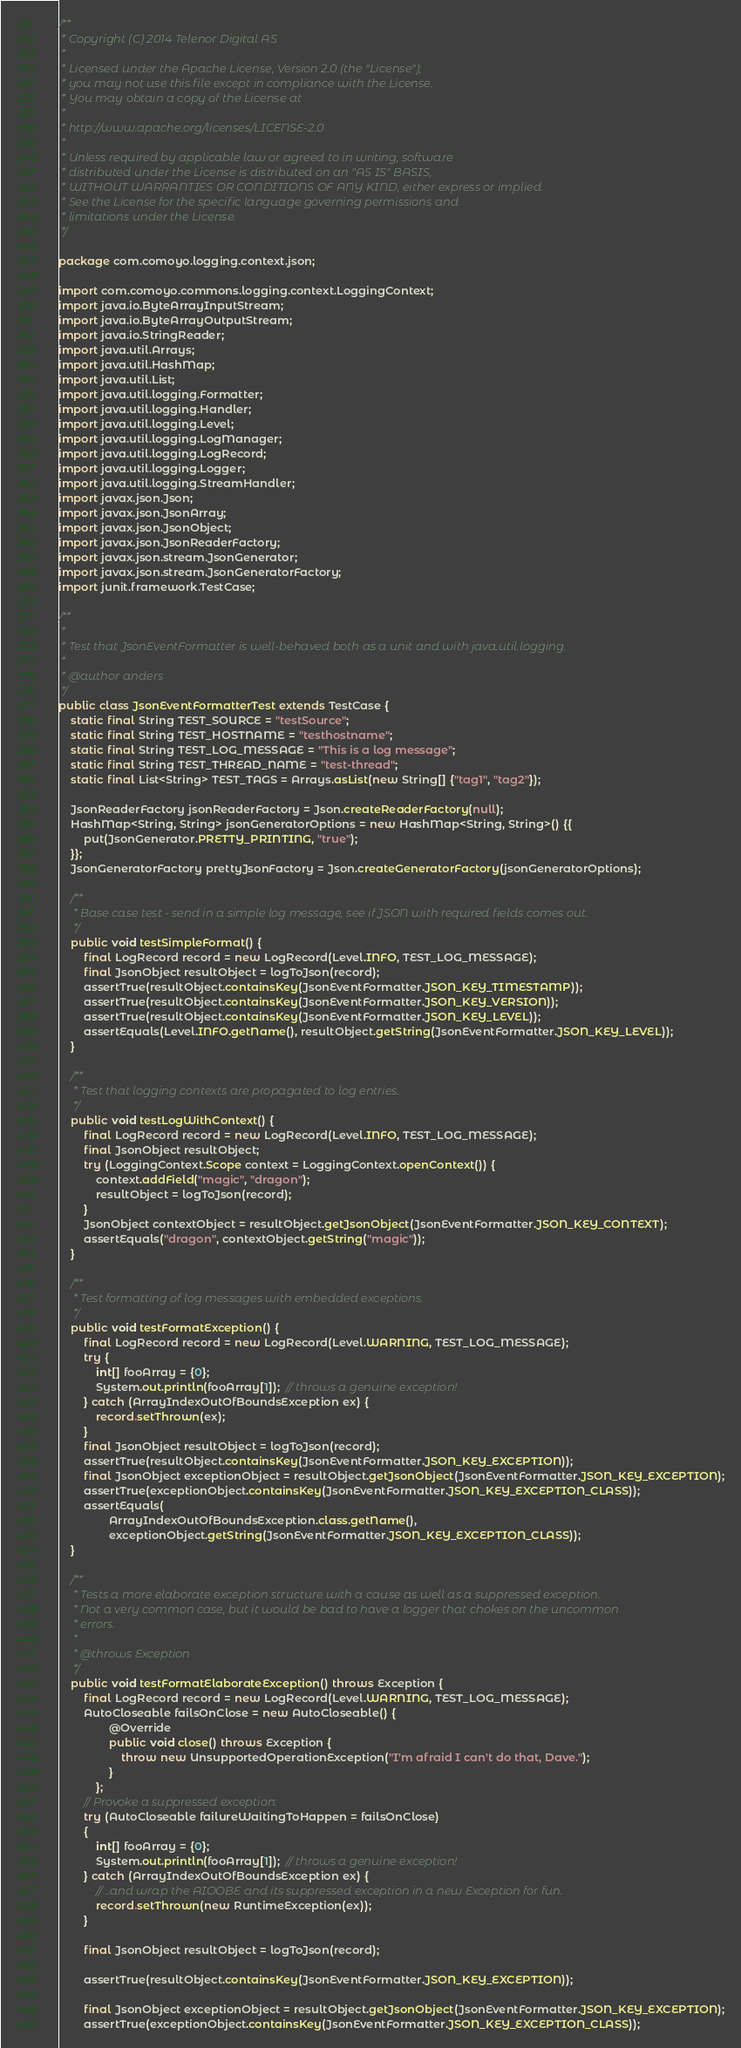Convert code to text. <code><loc_0><loc_0><loc_500><loc_500><_Java_>/**
 * Copyright (C) 2014 Telenor Digital AS
 *
 * Licensed under the Apache License, Version 2.0 (the "License");
 * you may not use this file except in compliance with the License.
 * You may obtain a copy of the License at
 *
 * http://www.apache.org/licenses/LICENSE-2.0
 *
 * Unless required by applicable law or agreed to in writing, software
 * distributed under the License is distributed on an "AS IS" BASIS,
 * WITHOUT WARRANTIES OR CONDITIONS OF ANY KIND, either express or implied.
 * See the License for the specific language governing permissions and
 * limitations under the License.
 */

package com.comoyo.logging.context.json;

import com.comoyo.commons.logging.context.LoggingContext;
import java.io.ByteArrayInputStream;
import java.io.ByteArrayOutputStream;
import java.io.StringReader;
import java.util.Arrays;
import java.util.HashMap;
import java.util.List;
import java.util.logging.Formatter;
import java.util.logging.Handler;
import java.util.logging.Level;
import java.util.logging.LogManager;
import java.util.logging.LogRecord;
import java.util.logging.Logger;
import java.util.logging.StreamHandler;
import javax.json.Json;
import javax.json.JsonArray;
import javax.json.JsonObject;
import javax.json.JsonReaderFactory;
import javax.json.stream.JsonGenerator;
import javax.json.stream.JsonGeneratorFactory;
import junit.framework.TestCase;

/**
 *
 * Test that JsonEventFormatter is well-behaved both as a unit and with java.util.logging.
 *
 * @author anders
 */
public class JsonEventFormatterTest extends TestCase {
    static final String TEST_SOURCE = "testSource";
    static final String TEST_HOSTNAME = "testhostname";
    static final String TEST_LOG_MESSAGE = "This is a log message";
    static final String TEST_THREAD_NAME = "test-thread";
    static final List<String> TEST_TAGS = Arrays.asList(new String[] {"tag1", "tag2"});

    JsonReaderFactory jsonReaderFactory = Json.createReaderFactory(null);
    HashMap<String, String> jsonGeneratorOptions = new HashMap<String, String>() {{
        put(JsonGenerator.PRETTY_PRINTING, "true");
    }};
    JsonGeneratorFactory prettyJsonFactory = Json.createGeneratorFactory(jsonGeneratorOptions);

    /**
     * Base case test - send in a simple log message, see if JSON with required fields comes out.
     */
    public void testSimpleFormat() {
        final LogRecord record = new LogRecord(Level.INFO, TEST_LOG_MESSAGE);
        final JsonObject resultObject = logToJson(record);
        assertTrue(resultObject.containsKey(JsonEventFormatter.JSON_KEY_TIMESTAMP));
        assertTrue(resultObject.containsKey(JsonEventFormatter.JSON_KEY_VERSION));
        assertTrue(resultObject.containsKey(JsonEventFormatter.JSON_KEY_LEVEL));
        assertEquals(Level.INFO.getName(), resultObject.getString(JsonEventFormatter.JSON_KEY_LEVEL));
    }

    /**
     * Test that logging contexts are propagated to log entries.
     */
    public void testLogWithContext() {
        final LogRecord record = new LogRecord(Level.INFO, TEST_LOG_MESSAGE);
        final JsonObject resultObject;
        try (LoggingContext.Scope context = LoggingContext.openContext()) {
            context.addField("magic", "dragon");
            resultObject = logToJson(record);
        }
        JsonObject contextObject = resultObject.getJsonObject(JsonEventFormatter.JSON_KEY_CONTEXT);
        assertEquals("dragon", contextObject.getString("magic"));
    }

    /**
     * Test formatting of log messages with embedded exceptions.
     */
    public void testFormatException() {
        final LogRecord record = new LogRecord(Level.WARNING, TEST_LOG_MESSAGE);
        try {
            int[] fooArray = {0};
            System.out.println(fooArray[1]);  // throws a genuine exception!
        } catch (ArrayIndexOutOfBoundsException ex) {
            record.setThrown(ex);
        }
        final JsonObject resultObject = logToJson(record);
        assertTrue(resultObject.containsKey(JsonEventFormatter.JSON_KEY_EXCEPTION));
        final JsonObject exceptionObject = resultObject.getJsonObject(JsonEventFormatter.JSON_KEY_EXCEPTION);
        assertTrue(exceptionObject.containsKey(JsonEventFormatter.JSON_KEY_EXCEPTION_CLASS));
        assertEquals(
                ArrayIndexOutOfBoundsException.class.getName(),
                exceptionObject.getString(JsonEventFormatter.JSON_KEY_EXCEPTION_CLASS));
    }

    /**
     * Tests a more elaborate exception structure with a cause as well as a suppressed exception.
     * Not a very common case, but it would be bad to have a logger that chokes on the uncommon
     * errors.
     *
     * @throws Exception
     */
    public void testFormatElaborateException() throws Exception {
        final LogRecord record = new LogRecord(Level.WARNING, TEST_LOG_MESSAGE);
        AutoCloseable failsOnClose = new AutoCloseable() {
                @Override
                public void close() throws Exception {
                    throw new UnsupportedOperationException("I'm afraid I can't do that, Dave.");
                }
            };
        // Provoke a suppressed exception:
        try (AutoCloseable failureWaitingToHappen = failsOnClose)
        {
            int[] fooArray = {0};
            System.out.println(fooArray[1]);  // throws a genuine exception!
        } catch (ArrayIndexOutOfBoundsException ex) {
            // ..and wrap the AIOOBE and its suppressed exception in a new Exception for fun.
            record.setThrown(new RuntimeException(ex));
        }

        final JsonObject resultObject = logToJson(record);

        assertTrue(resultObject.containsKey(JsonEventFormatter.JSON_KEY_EXCEPTION));

        final JsonObject exceptionObject = resultObject.getJsonObject(JsonEventFormatter.JSON_KEY_EXCEPTION);
        assertTrue(exceptionObject.containsKey(JsonEventFormatter.JSON_KEY_EXCEPTION_CLASS));
</code> 